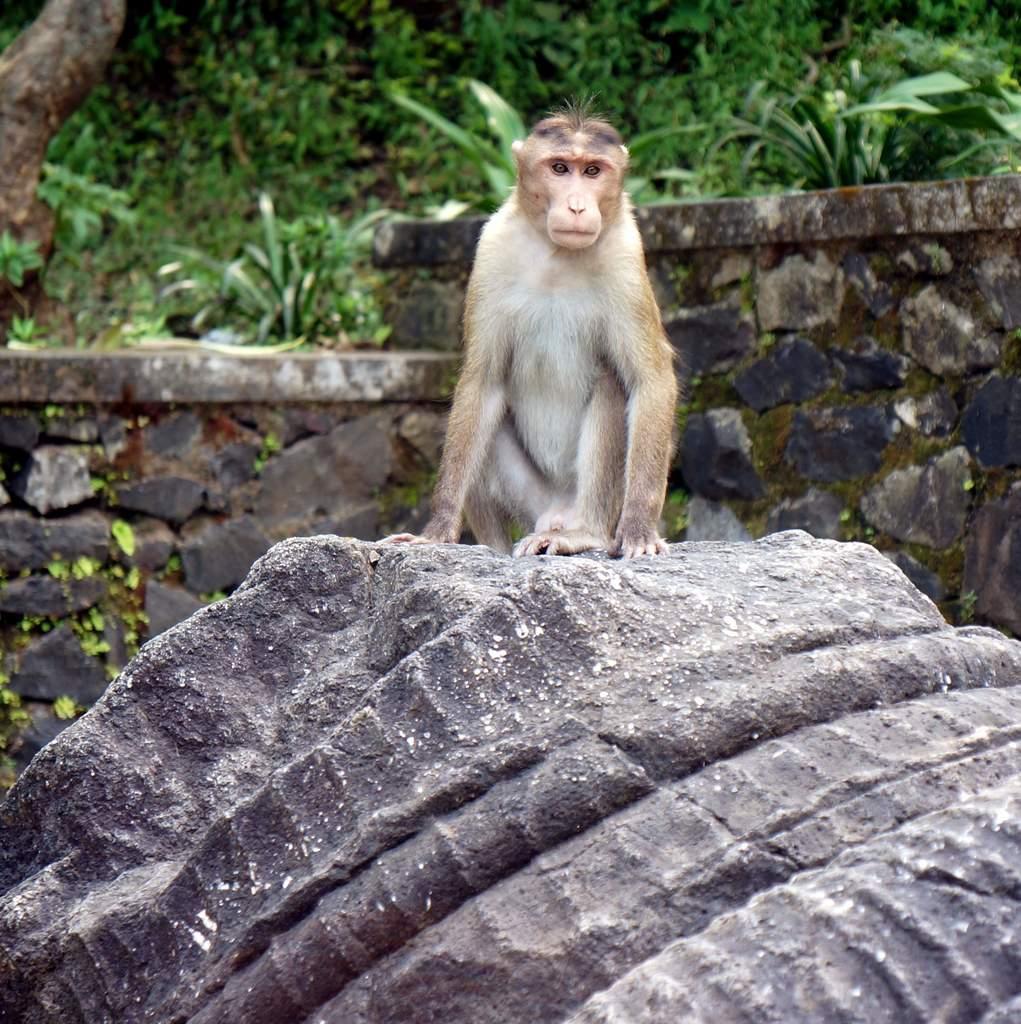What object is the main focus of the image? There is a stone in the image. What is on top of the stone? A monkey is sitting on the stone. What can be seen in the background of the image? There is a wall and plants in the background of the image. What type of thread is being sold at the market in the image? There is no market or thread present in the image; it features a stone with a monkey sitting on it and a background with a wall and plants. 